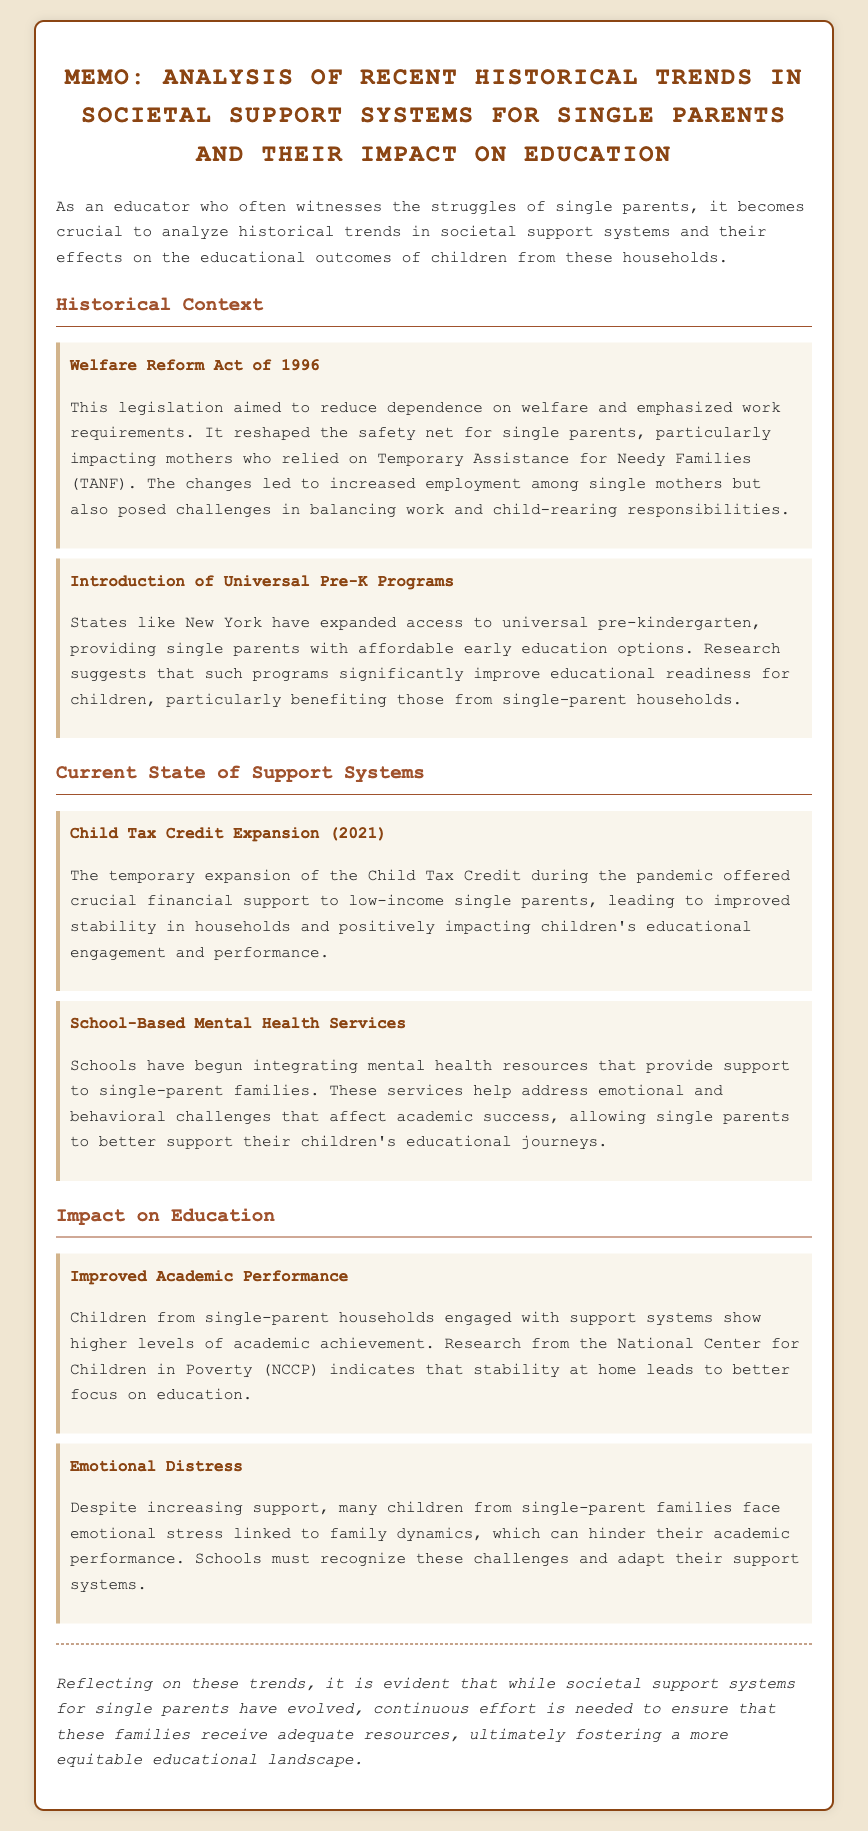What legislation aimed to reduce dependence on welfare? The document mentions the Welfare Reform Act of 1996, which focused on decreasing welfare dependence.
Answer: Welfare Reform Act of 1996 What program was introduced to provide affordable early education options? The memo details the introduction of Universal Pre-K Programs, specifically in states like New York.
Answer: Universal Pre-K Programs What significant change occurred with the Child Tax Credit in 2021? The memo states that the Child Tax Credit was temporarily expanded, providing increased financial support to low-income single parents during the pandemic.
Answer: Expansion in 2021 Which organization conducted research indicating that stability at home leads to better focus on education? The document cites the National Center for Children in Poverty as the source of research related to academic achievement among children from stable homes.
Answer: National Center for Children in Poverty What issue do many children from single-parent families face despite increasing support? The memo highlights that children often experience emotional distress linked to their family dynamics.
Answer: Emotional distress How do school-based mental health services contribute to education? The document explains that these services help address emotional and behavioral challenges, allowing single parents to better support their children's education.
Answer: Support for educational journeys What conclusion is drawn about societal support systems for single parents? The memo concludes that although these systems have evolved, there remains a need for continuous efforts to ensure adequate resources for single-parent families.
Answer: Continuous effort needed 